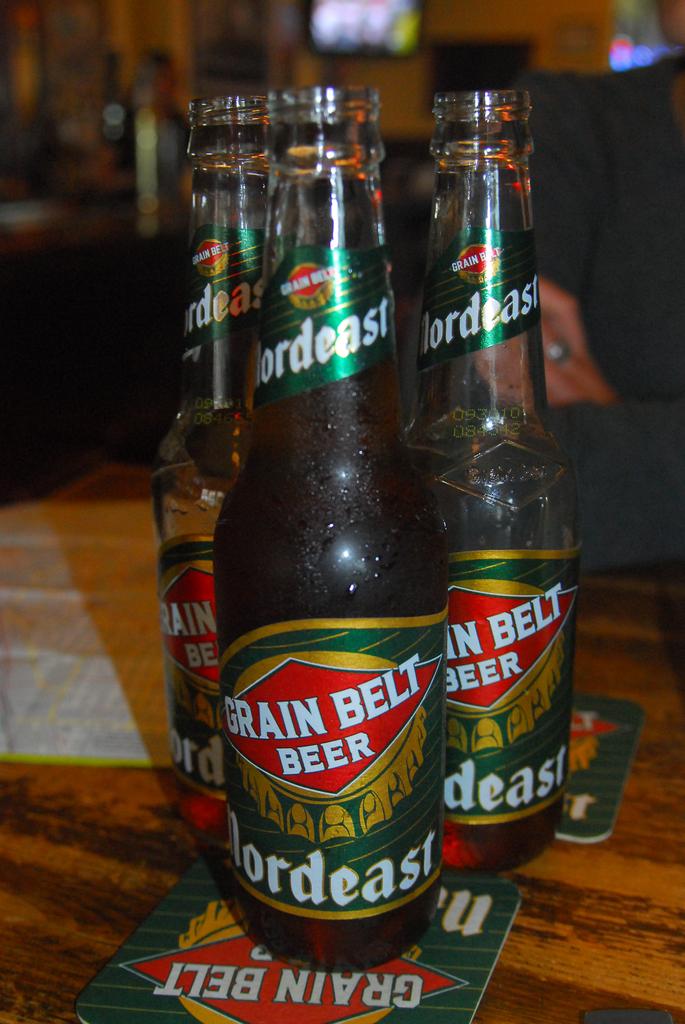What kinf of beer is this?
Provide a short and direct response. Grain belt. What brand is the grain belt beer?
Provide a succinct answer. Nordeast. 